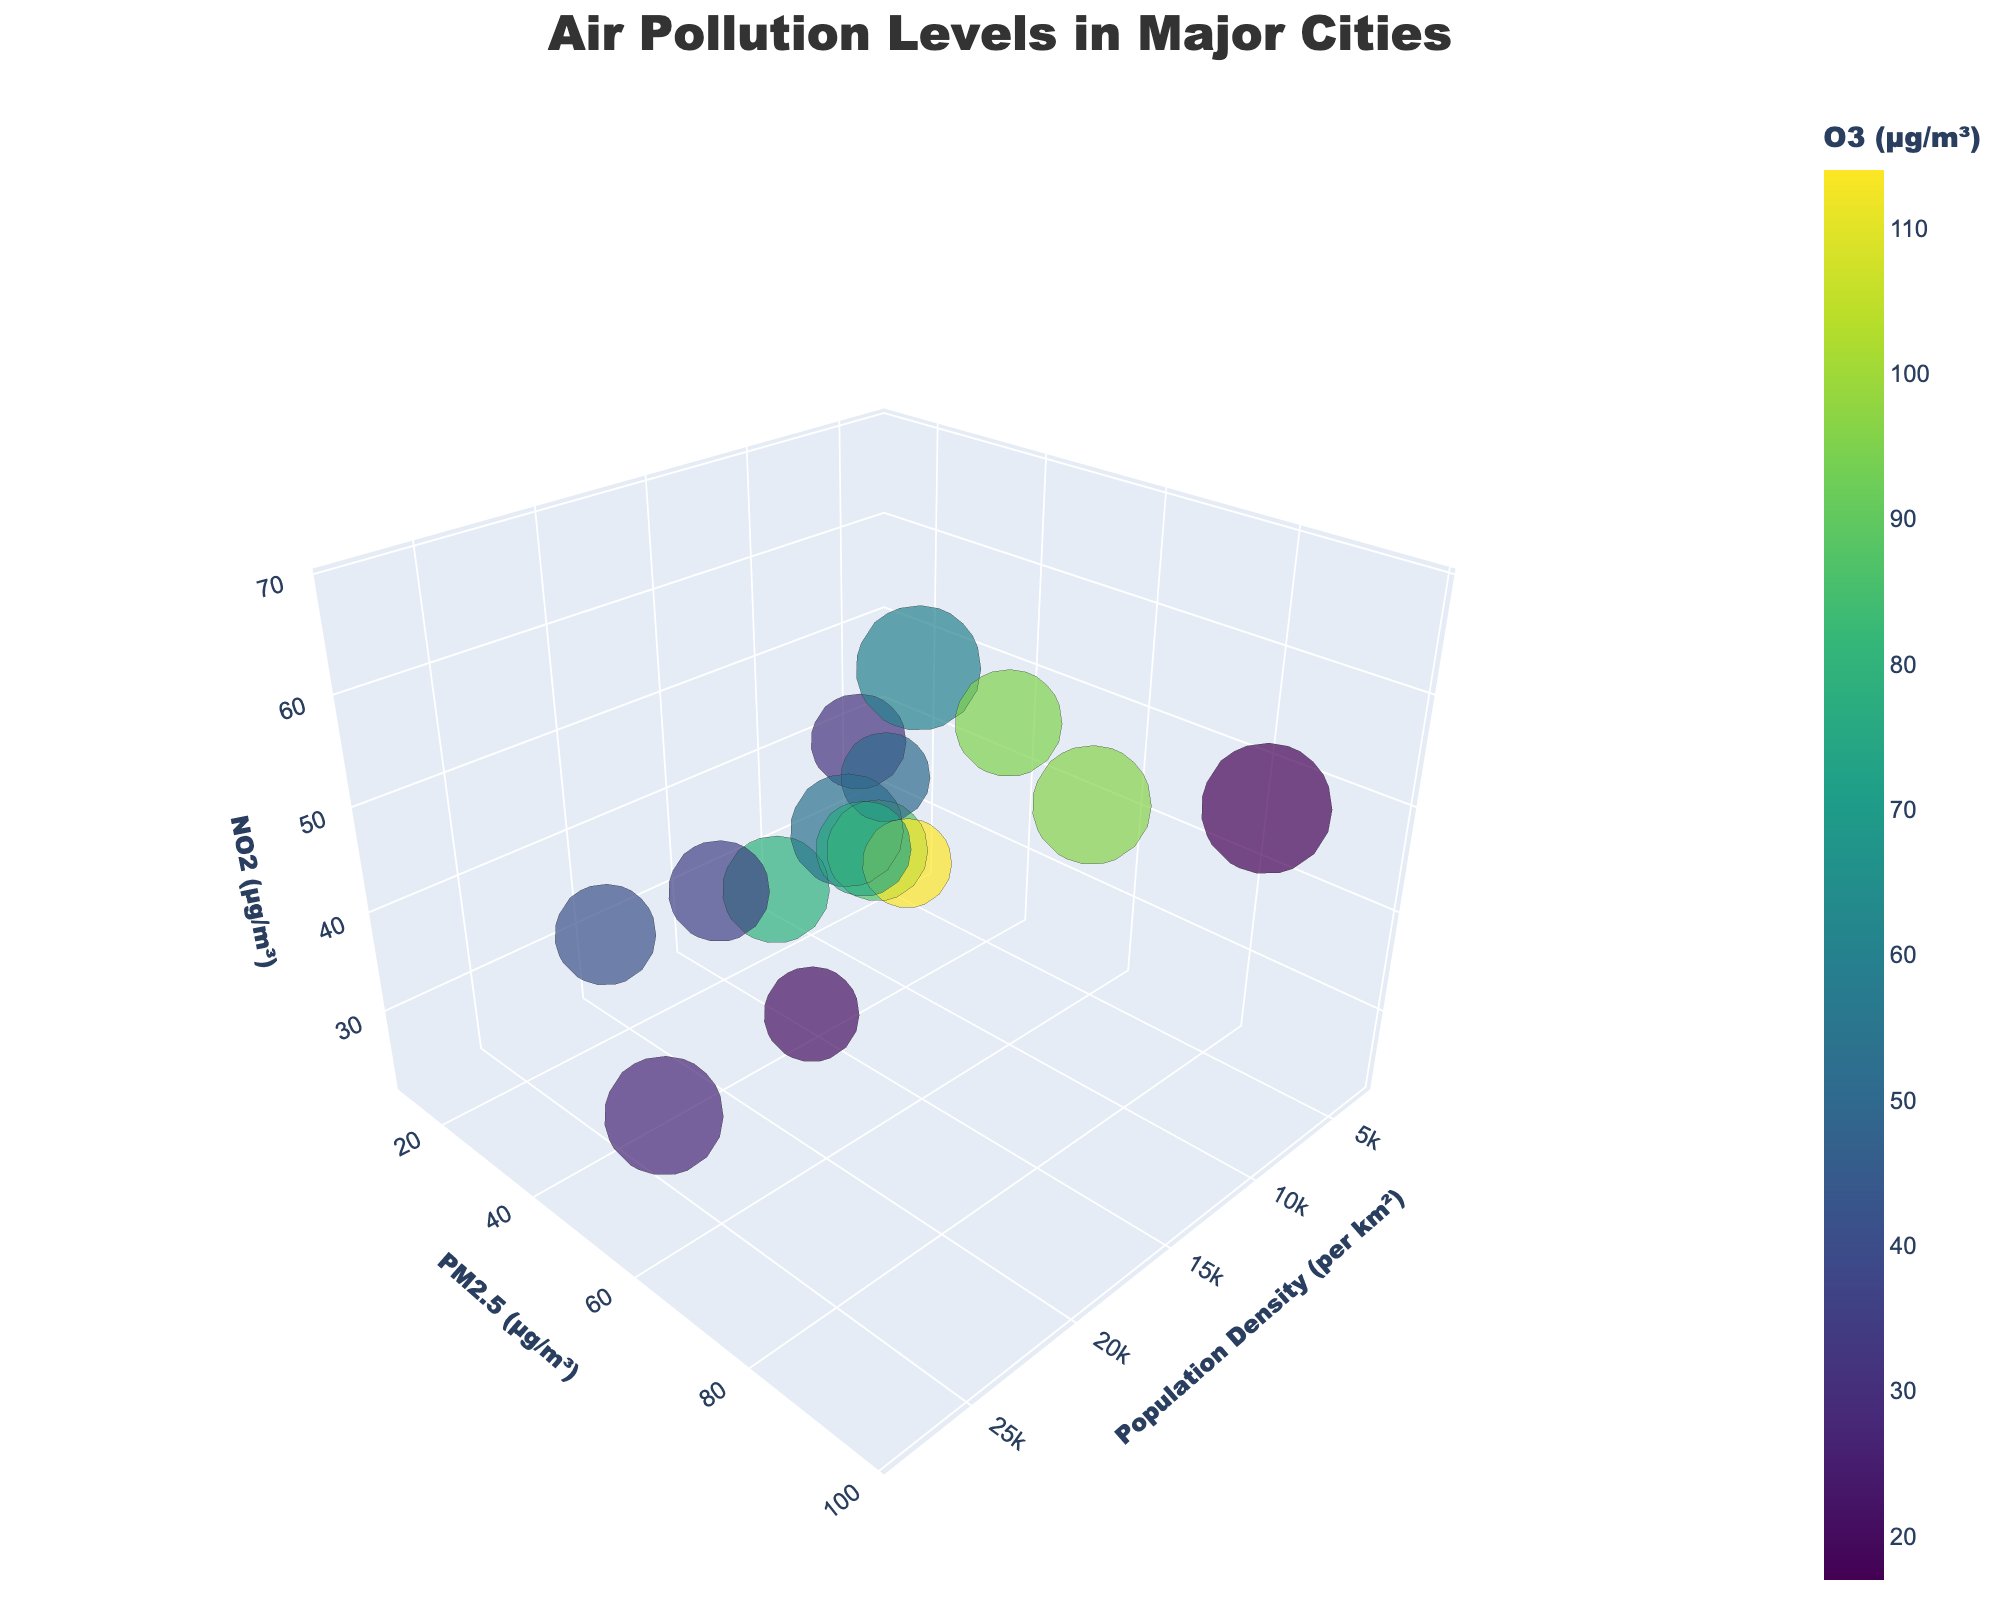What is the title of the figure? The title is located at the top of the figure. It should succinctly describe the main subject of the chart.
Answer: Air Pollution Levels in Major Cities How many cities have their population density greater than 15000 per km²? By examining the x-axis values, identifying cities with population density greater than 15000 per km² are performed. There are three cities: Cairo, Mumbai, and Paris.
Answer: 3 Which city has the highest value of PM2.5? Observing the y-axis where PM2.5 values are plotted, the highest PM2.5 is associated with Delhi.
Answer: Delhi Between Beijing and Tokyo, which city has higher NO2 levels? Comparing the z-axis values for Beijing and Tokyo, Beijing's NO2 value is 42 while Tokyo has 29. Thus, Beijing has higher NO2 levels.
Answer: Beijing What is the general relationship between population density and PM2.5 levels? By observing the distribution of the bubbles across the x-axis (population density) and y-axis (PM2.5 levels), a pattern appears that cities with higher population density also tend to have higher PM2.5 levels.
Answer: Higher population density often correlates with higher PM2.5 levels Which city with a population density below 5000 per km² has the highest O3 levels? Filtering the cities with population densities less than 5000 per km² and then checking the O3 levels, Los Angeles has the highest at 114 µg/m³.
Answer: Los Angeles What is the rank of New York in terms of NO2 levels from highest to lowest? Listing all cities by their NO2 levels in descending order, New York's NO2 (25 µg/m³) places it at 10th.
Answer: 10th Which city has the largest bubble size and what does it represent? Observing the marker (bubble) sizes, the largest bubble size belongs to Delhi, with a value of 22. This represents some specific measure denoted as 'Bubble Size' in the data.
Answer: Delhi What can be inferred about air pollution in cities with high population density and high NO2 levels? Examination of the relationship between population density and NO2 levels suggests that cities with both high population density and high NO2 levels also show significant air pollution across multiple pollutants such as PM2.5 and O3.
Answer: They tend to have high levels of multiple air pollutants Which city among those with a population density between 5000 and 10000 per km² has the lowest PM2.5 levels? Filtering for cities in the specified population density range and then examining the y-axis for PM2.5 levels shows that Tokyo has the lowest PM2.5 at 14 µg/m³.
Answer: Tokyo 